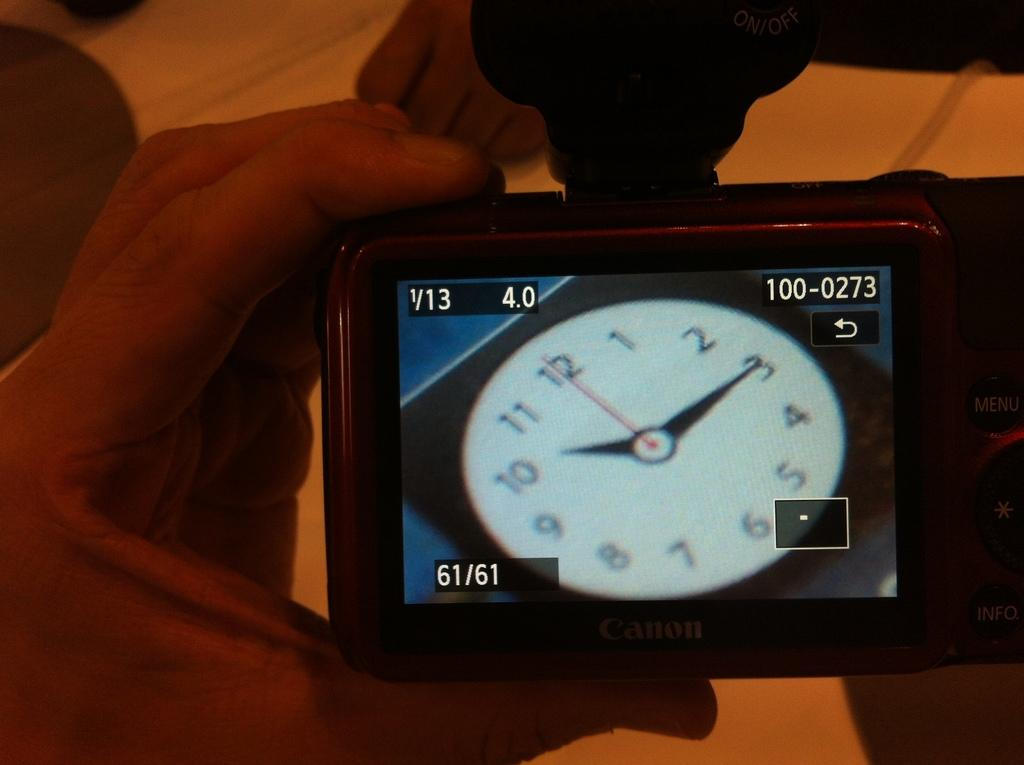<image>
Relay a brief, clear account of the picture shown. A clock is showing that the time is 10:15. 